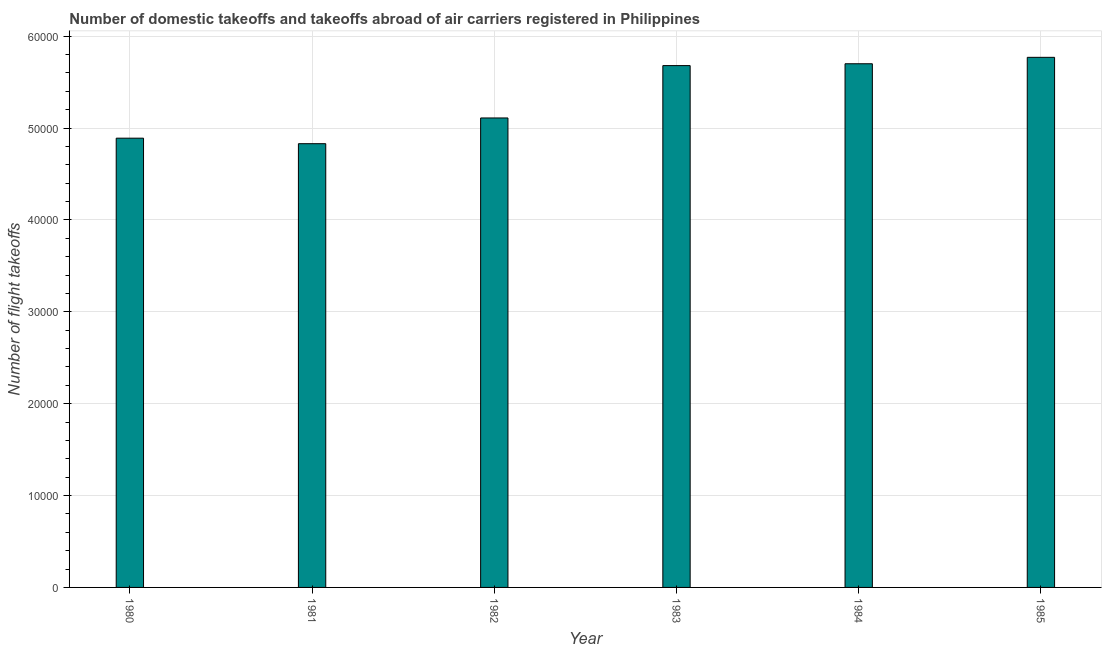Does the graph contain grids?
Your response must be concise. Yes. What is the title of the graph?
Offer a terse response. Number of domestic takeoffs and takeoffs abroad of air carriers registered in Philippines. What is the label or title of the Y-axis?
Offer a terse response. Number of flight takeoffs. What is the number of flight takeoffs in 1985?
Your answer should be compact. 5.77e+04. Across all years, what is the maximum number of flight takeoffs?
Your answer should be very brief. 5.77e+04. Across all years, what is the minimum number of flight takeoffs?
Offer a very short reply. 4.83e+04. In which year was the number of flight takeoffs maximum?
Ensure brevity in your answer.  1985. What is the sum of the number of flight takeoffs?
Your response must be concise. 3.20e+05. What is the difference between the number of flight takeoffs in 1983 and 1984?
Your answer should be very brief. -200. What is the average number of flight takeoffs per year?
Ensure brevity in your answer.  5.33e+04. What is the median number of flight takeoffs?
Provide a succinct answer. 5.40e+04. In how many years, is the number of flight takeoffs greater than 2000 ?
Your answer should be compact. 6. What is the ratio of the number of flight takeoffs in 1980 to that in 1983?
Offer a very short reply. 0.86. What is the difference between the highest and the second highest number of flight takeoffs?
Keep it short and to the point. 700. What is the difference between the highest and the lowest number of flight takeoffs?
Offer a very short reply. 9400. In how many years, is the number of flight takeoffs greater than the average number of flight takeoffs taken over all years?
Keep it short and to the point. 3. What is the difference between two consecutive major ticks on the Y-axis?
Your answer should be compact. 10000. Are the values on the major ticks of Y-axis written in scientific E-notation?
Provide a succinct answer. No. What is the Number of flight takeoffs of 1980?
Keep it short and to the point. 4.89e+04. What is the Number of flight takeoffs of 1981?
Your answer should be very brief. 4.83e+04. What is the Number of flight takeoffs in 1982?
Keep it short and to the point. 5.11e+04. What is the Number of flight takeoffs of 1983?
Offer a very short reply. 5.68e+04. What is the Number of flight takeoffs in 1984?
Provide a short and direct response. 5.70e+04. What is the Number of flight takeoffs of 1985?
Offer a terse response. 5.77e+04. What is the difference between the Number of flight takeoffs in 1980 and 1981?
Give a very brief answer. 600. What is the difference between the Number of flight takeoffs in 1980 and 1982?
Provide a short and direct response. -2200. What is the difference between the Number of flight takeoffs in 1980 and 1983?
Give a very brief answer. -7900. What is the difference between the Number of flight takeoffs in 1980 and 1984?
Give a very brief answer. -8100. What is the difference between the Number of flight takeoffs in 1980 and 1985?
Make the answer very short. -8800. What is the difference between the Number of flight takeoffs in 1981 and 1982?
Your response must be concise. -2800. What is the difference between the Number of flight takeoffs in 1981 and 1983?
Keep it short and to the point. -8500. What is the difference between the Number of flight takeoffs in 1981 and 1984?
Your answer should be compact. -8700. What is the difference between the Number of flight takeoffs in 1981 and 1985?
Provide a succinct answer. -9400. What is the difference between the Number of flight takeoffs in 1982 and 1983?
Your answer should be very brief. -5700. What is the difference between the Number of flight takeoffs in 1982 and 1984?
Give a very brief answer. -5900. What is the difference between the Number of flight takeoffs in 1982 and 1985?
Your answer should be very brief. -6600. What is the difference between the Number of flight takeoffs in 1983 and 1984?
Provide a succinct answer. -200. What is the difference between the Number of flight takeoffs in 1983 and 1985?
Your answer should be very brief. -900. What is the difference between the Number of flight takeoffs in 1984 and 1985?
Provide a short and direct response. -700. What is the ratio of the Number of flight takeoffs in 1980 to that in 1982?
Your answer should be compact. 0.96. What is the ratio of the Number of flight takeoffs in 1980 to that in 1983?
Your answer should be compact. 0.86. What is the ratio of the Number of flight takeoffs in 1980 to that in 1984?
Offer a terse response. 0.86. What is the ratio of the Number of flight takeoffs in 1980 to that in 1985?
Ensure brevity in your answer.  0.85. What is the ratio of the Number of flight takeoffs in 1981 to that in 1982?
Your response must be concise. 0.94. What is the ratio of the Number of flight takeoffs in 1981 to that in 1984?
Give a very brief answer. 0.85. What is the ratio of the Number of flight takeoffs in 1981 to that in 1985?
Your answer should be very brief. 0.84. What is the ratio of the Number of flight takeoffs in 1982 to that in 1984?
Ensure brevity in your answer.  0.9. What is the ratio of the Number of flight takeoffs in 1982 to that in 1985?
Your answer should be very brief. 0.89. What is the ratio of the Number of flight takeoffs in 1984 to that in 1985?
Offer a terse response. 0.99. 